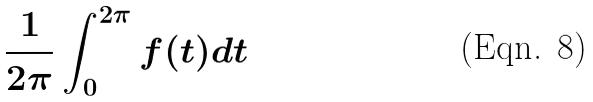Convert formula to latex. <formula><loc_0><loc_0><loc_500><loc_500>\frac { 1 } { 2 \pi } \int _ { 0 } ^ { 2 \pi } f ( t ) d t</formula> 